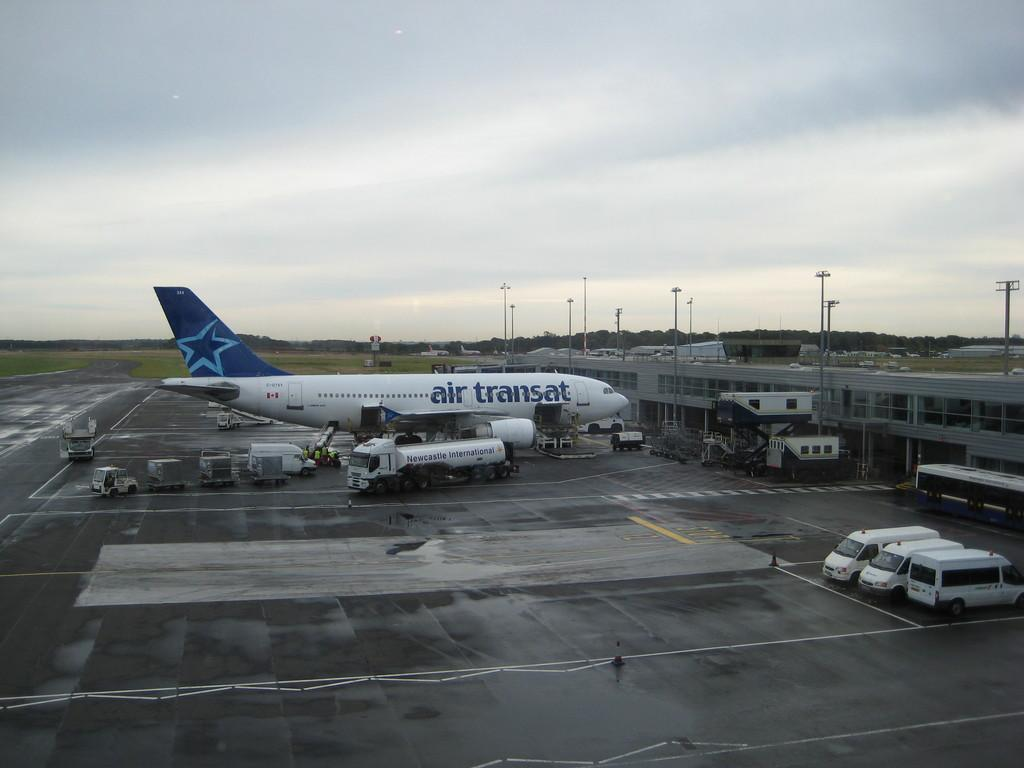Provide a one-sentence caption for the provided image. a plane in a hanger with Air Transat on the side. 